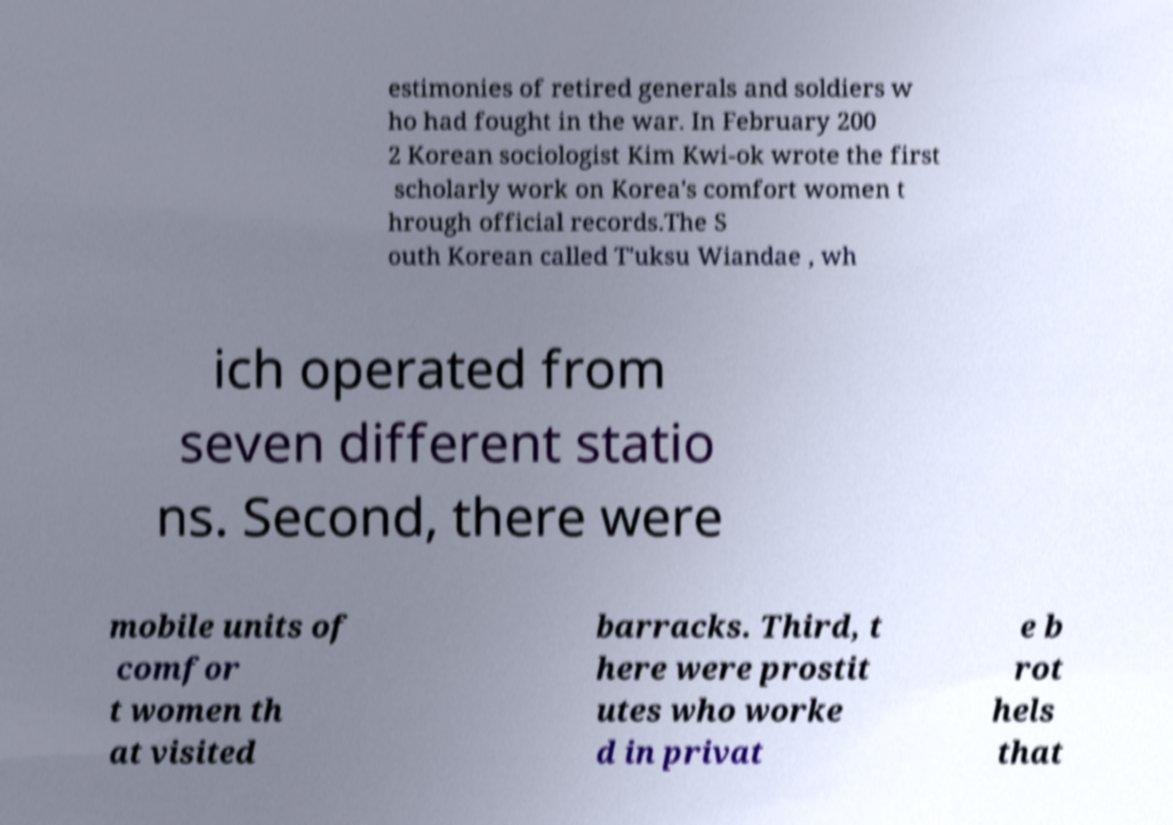Can you read and provide the text displayed in the image?This photo seems to have some interesting text. Can you extract and type it out for me? estimonies of retired generals and soldiers w ho had fought in the war. In February 200 2 Korean sociologist Kim Kwi-ok wrote the first scholarly work on Korea's comfort women t hrough official records.The S outh Korean called T'uksu Wiandae , wh ich operated from seven different statio ns. Second, there were mobile units of comfor t women th at visited barracks. Third, t here were prostit utes who worke d in privat e b rot hels that 